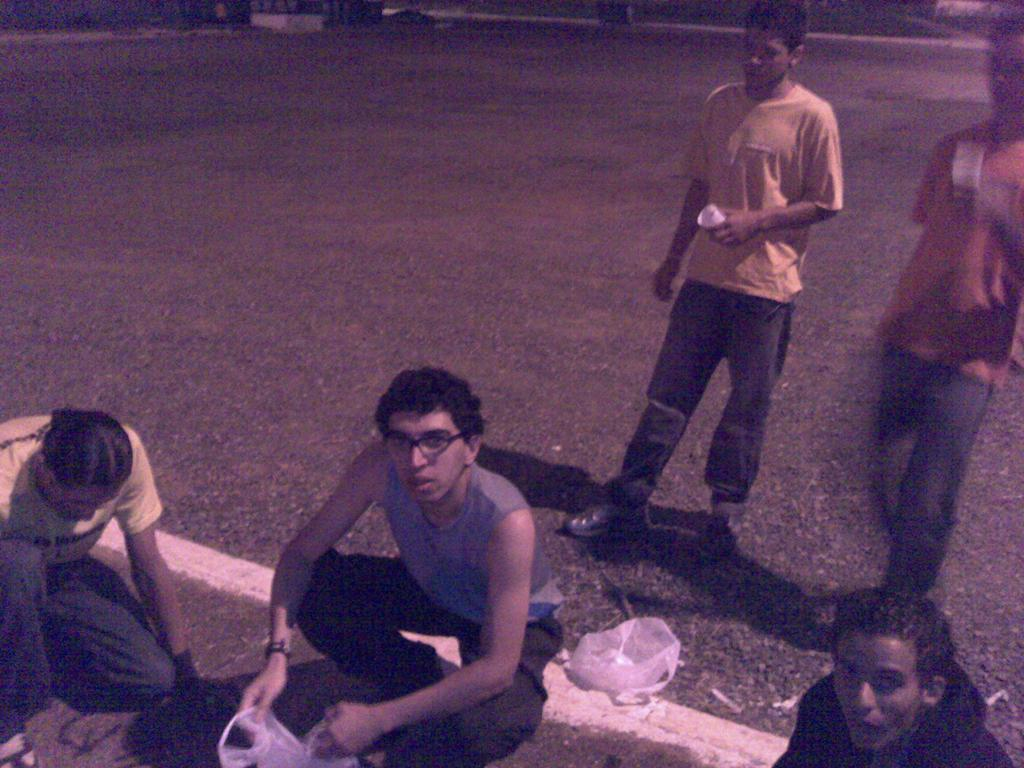How many people are in the image? There are people in the image, but the exact number is not specified. What are some of the people doing in the image? Some of the people are holding objects, while others are sitting or standing. What can be seen in the background of the image? The road is visible in the image. How much did the brothers pay for the boy in the image? There is no mention of brothers, payment, or a boy in the image. The image only features people, some of whom are holding objects, sitting, or standing, and a visible road in the background. 